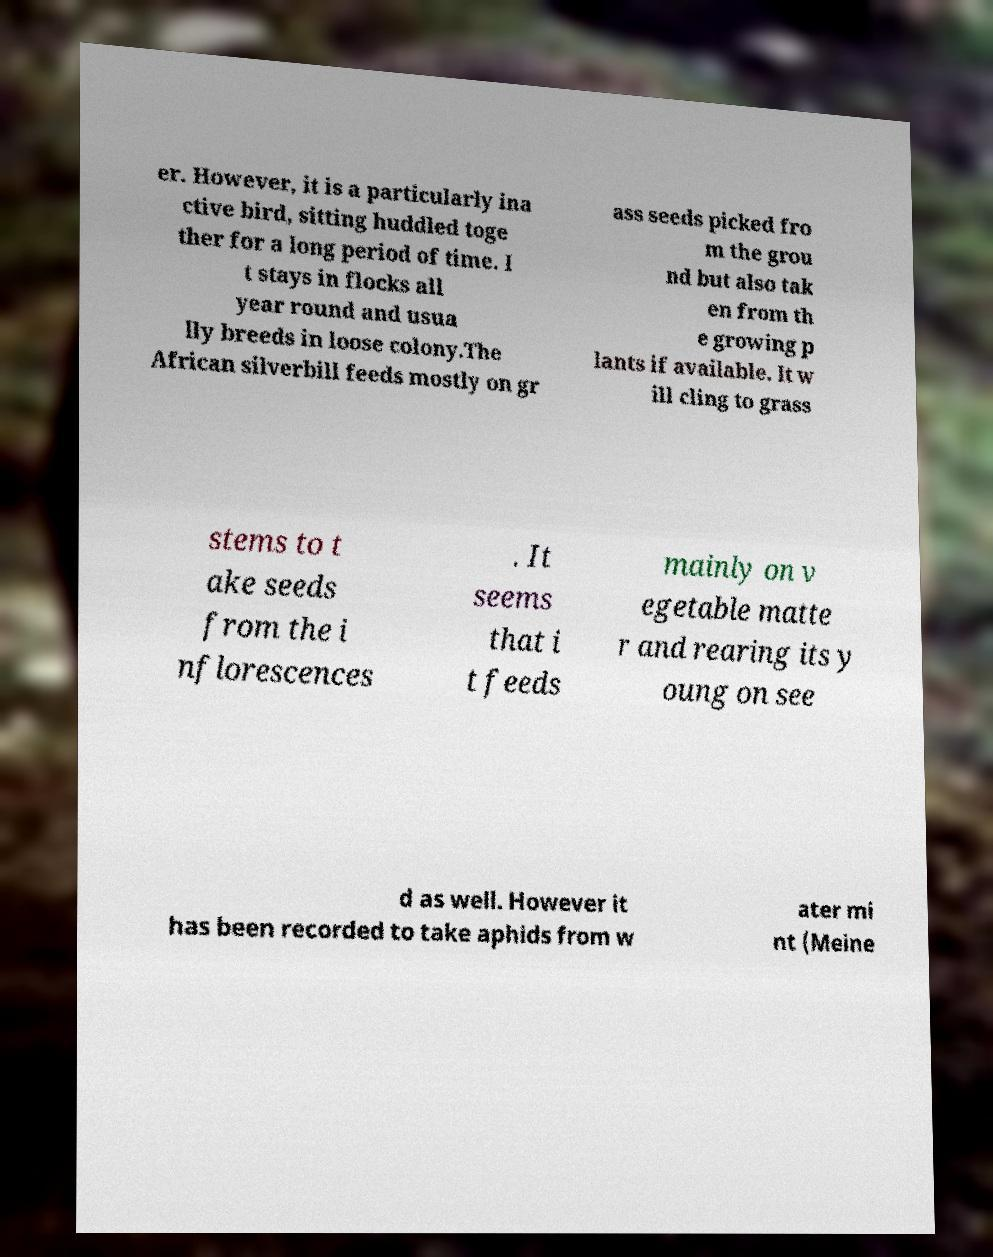Could you assist in decoding the text presented in this image and type it out clearly? er. However, it is a particularly ina ctive bird, sitting huddled toge ther for a long period of time. I t stays in flocks all year round and usua lly breeds in loose colony.The African silverbill feeds mostly on gr ass seeds picked fro m the grou nd but also tak en from th e growing p lants if available. It w ill cling to grass stems to t ake seeds from the i nflorescences . It seems that i t feeds mainly on v egetable matte r and rearing its y oung on see d as well. However it has been recorded to take aphids from w ater mi nt (Meine 